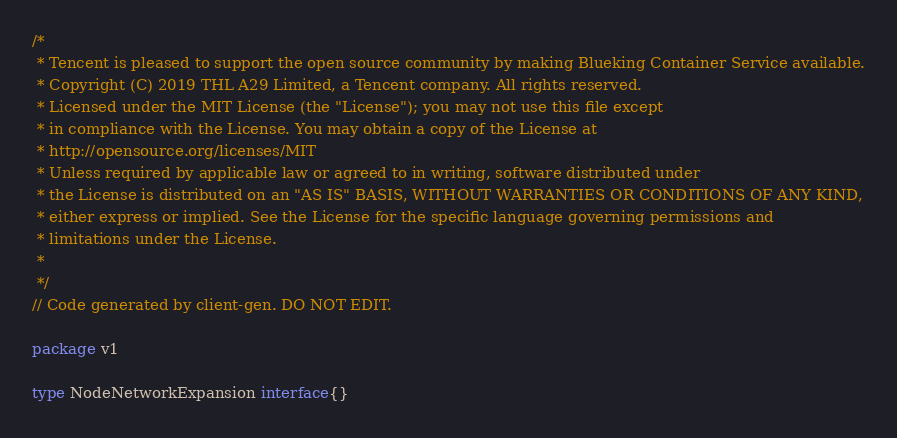Convert code to text. <code><loc_0><loc_0><loc_500><loc_500><_Go_>/*
 * Tencent is pleased to support the open source community by making Blueking Container Service available.
 * Copyright (C) 2019 THL A29 Limited, a Tencent company. All rights reserved.
 * Licensed under the MIT License (the "License"); you may not use this file except
 * in compliance with the License. You may obtain a copy of the License at
 * http://opensource.org/licenses/MIT
 * Unless required by applicable law or agreed to in writing, software distributed under
 * the License is distributed on an "AS IS" BASIS, WITHOUT WARRANTIES OR CONDITIONS OF ANY KIND,
 * either express or implied. See the License for the specific language governing permissions and
 * limitations under the License.
 *
 */
// Code generated by client-gen. DO NOT EDIT.

package v1

type NodeNetworkExpansion interface{}
</code> 